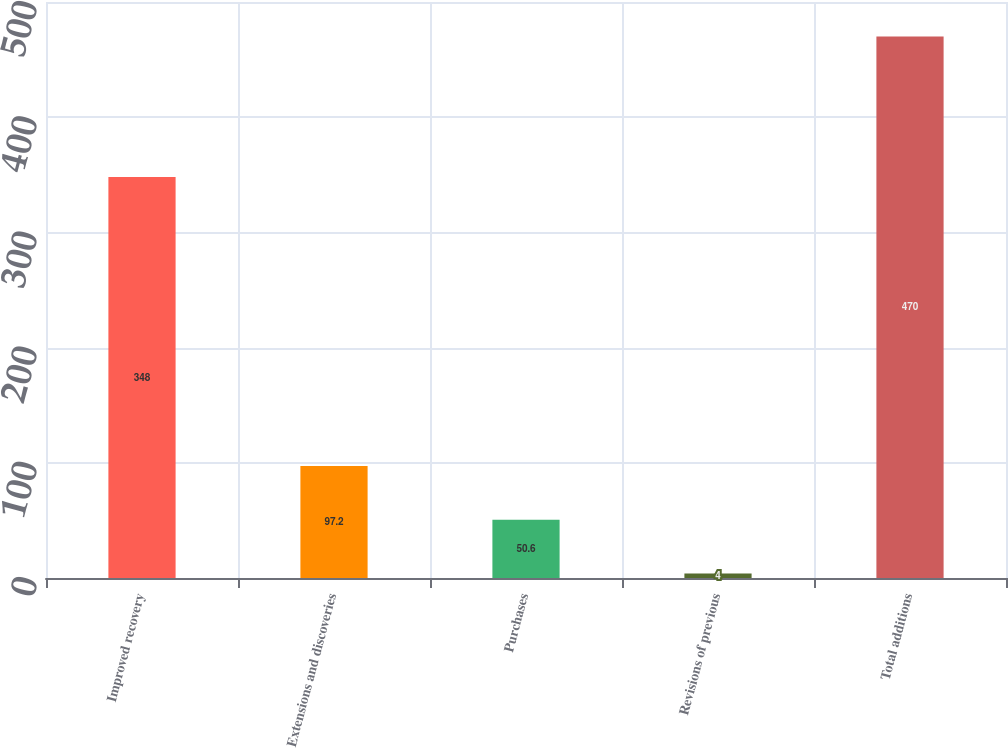<chart> <loc_0><loc_0><loc_500><loc_500><bar_chart><fcel>Improved recovery<fcel>Extensions and discoveries<fcel>Purchases<fcel>Revisions of previous<fcel>Total additions<nl><fcel>348<fcel>97.2<fcel>50.6<fcel>4<fcel>470<nl></chart> 